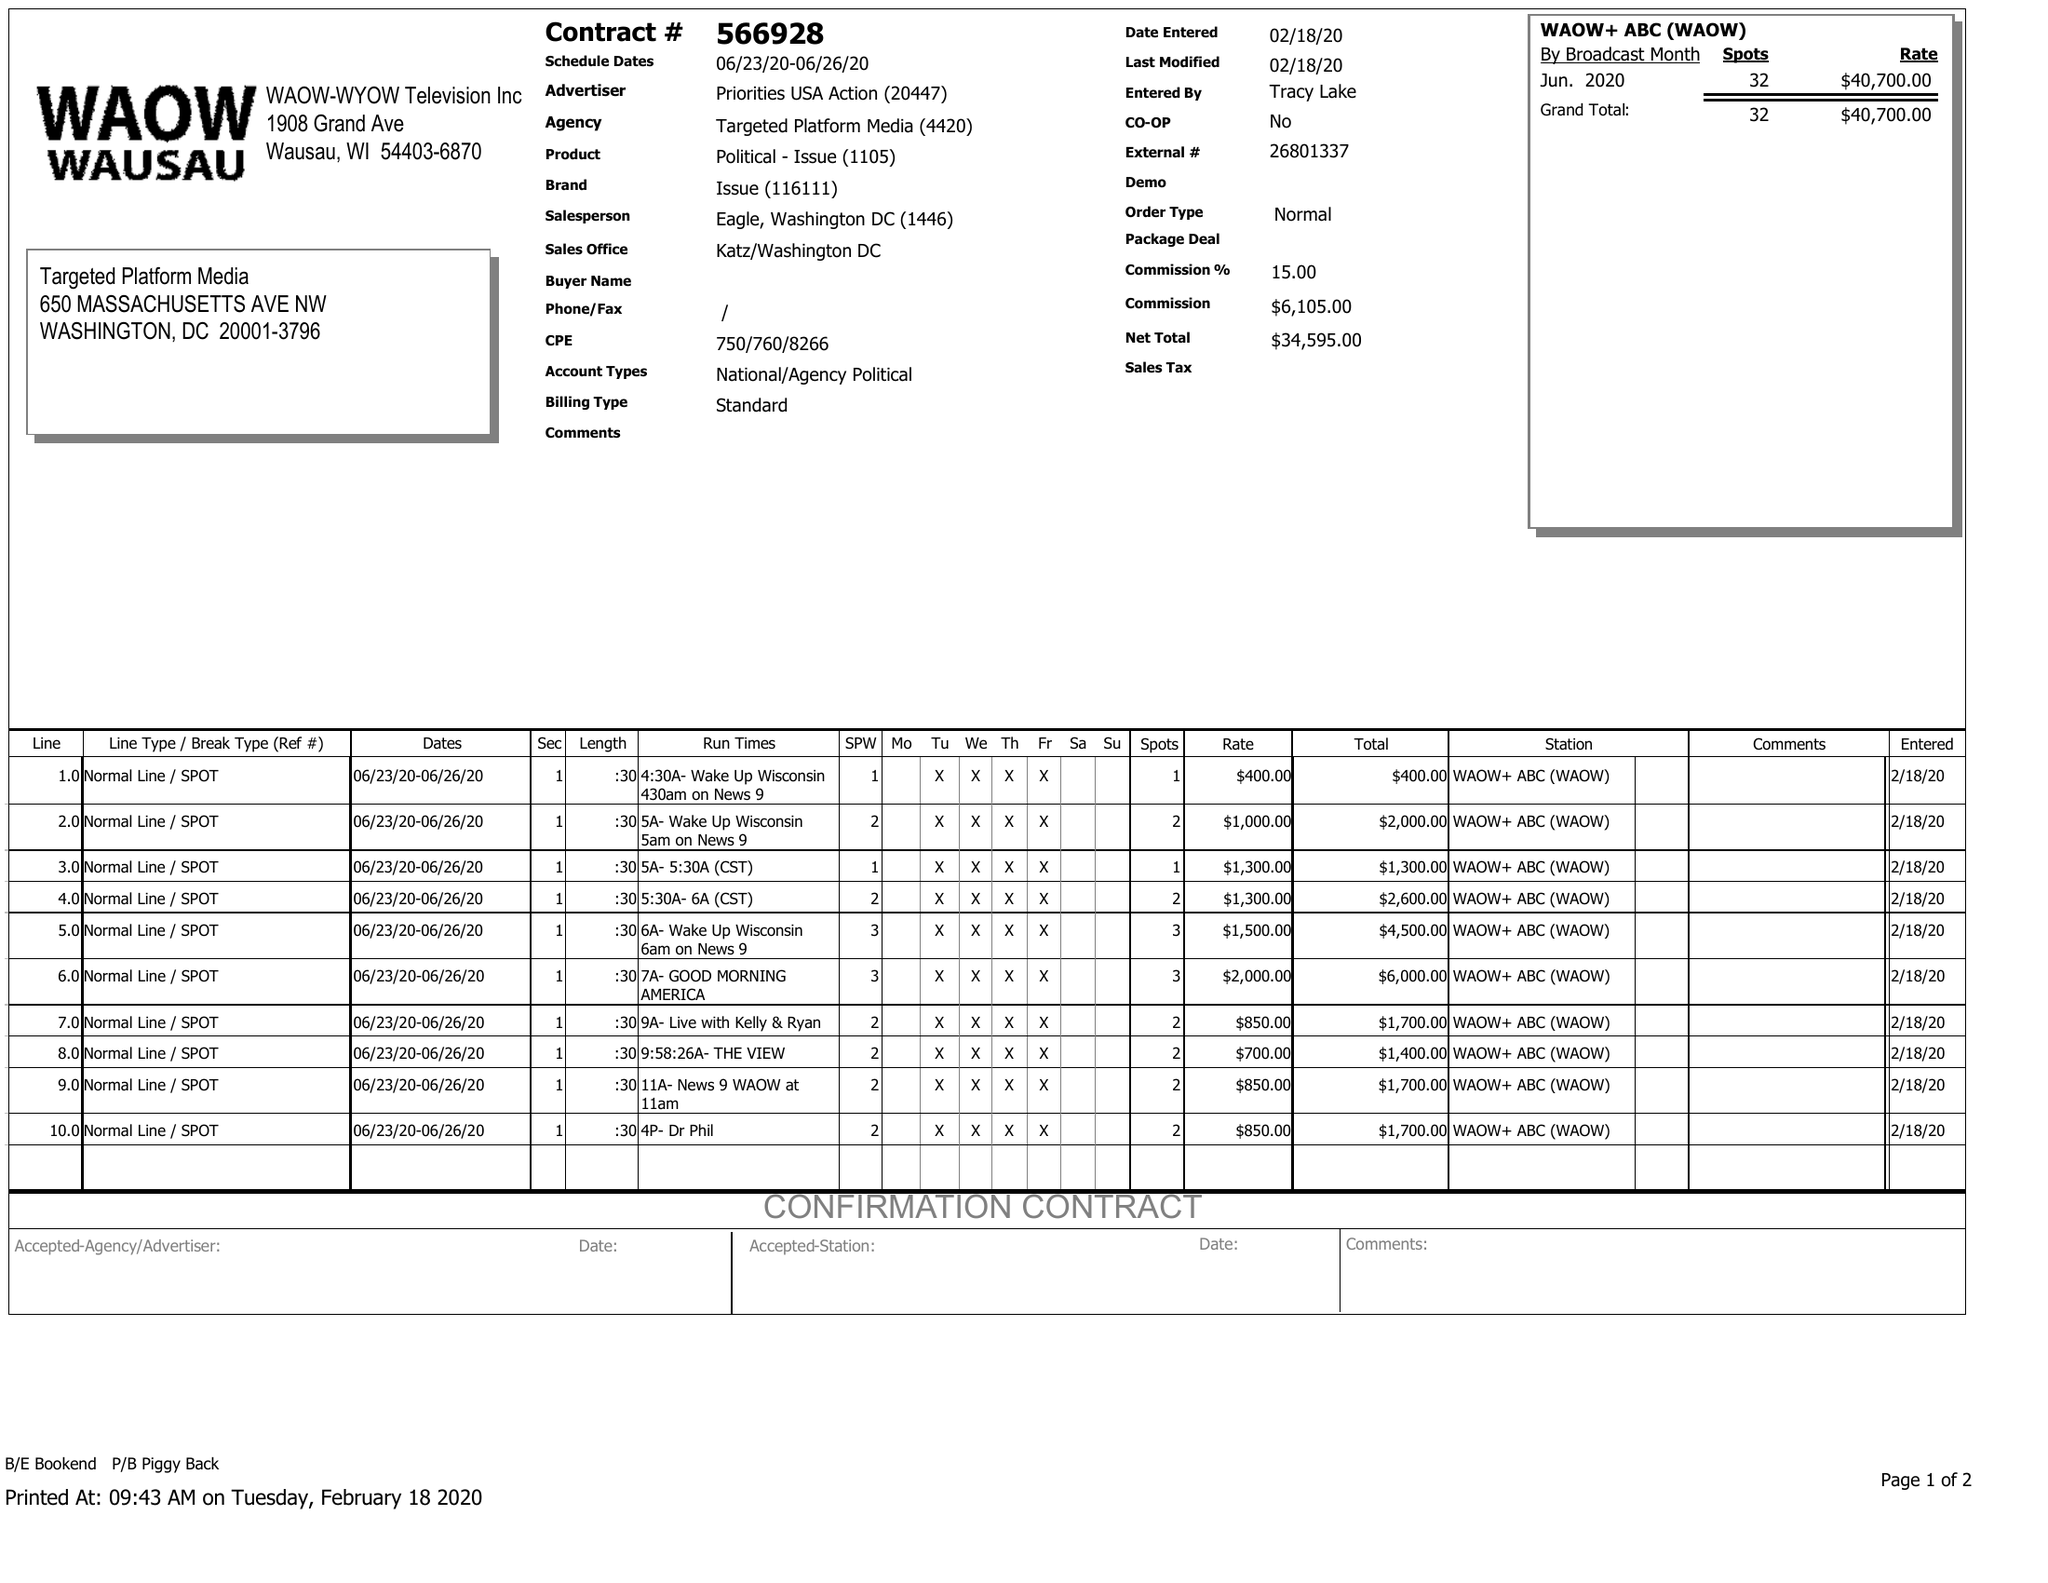What is the value for the advertiser?
Answer the question using a single word or phrase. PRIORITIES USA ACTION 